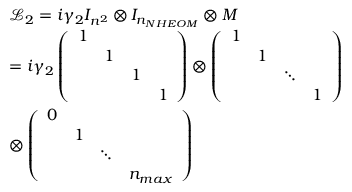Convert formula to latex. <formula><loc_0><loc_0><loc_500><loc_500>\begin{array} { r l } & { { \mathcal { L } _ { 2 } } = i { { \gamma } _ { 2 } } { { I } _ { { { n } ^ { 2 } } } } \otimes { { I } _ { { { n } _ { N H E O M } } } } \otimes M } \\ & { = i { { \gamma } _ { 2 } } \left ( \begin{array} { l l l l } { 1 } & { 1 } & { 1 } & { 1 } \end{array} \right ) \otimes \left ( \begin{array} { l l l l } { 1 } & { 1 } & { \ddots } & { 1 } \end{array} \right ) } \\ & { \otimes \left ( \begin{array} { l l l l } { 0 } & { 1 } & { \ddots } & { { { n } _ { \max } } } \end{array} \right ) } \end{array}</formula> 